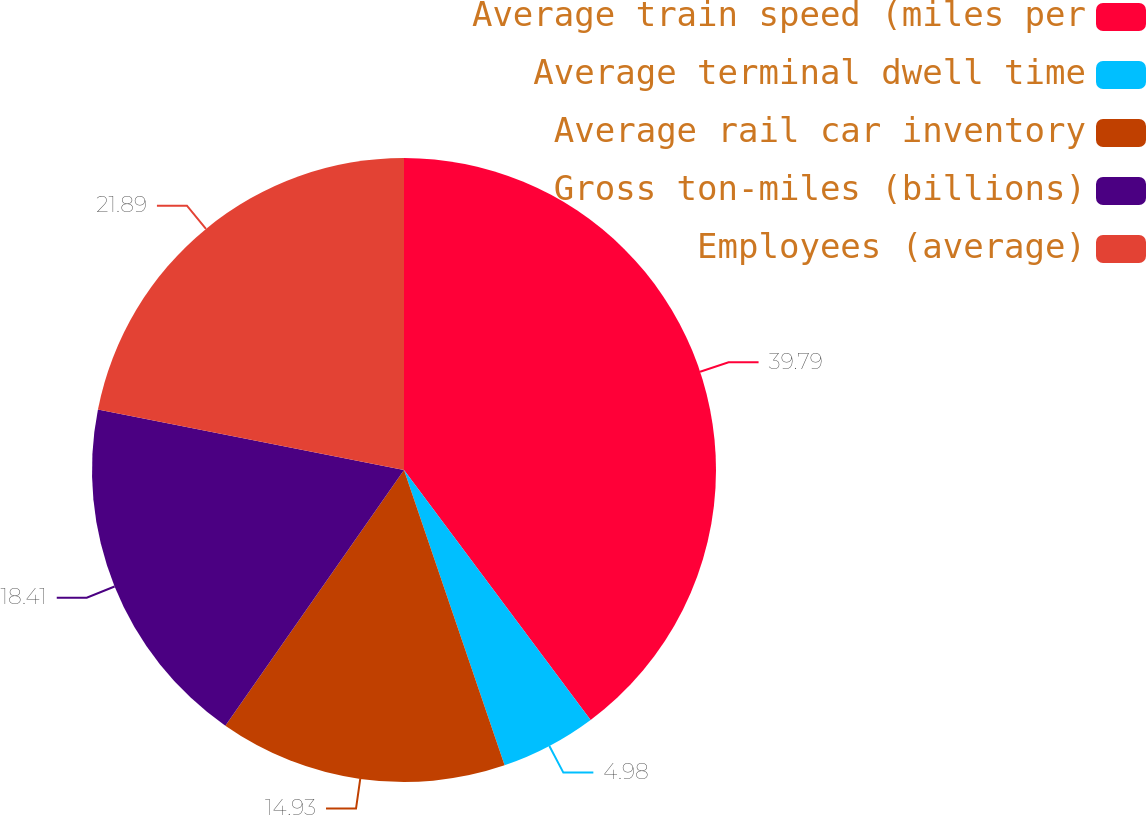<chart> <loc_0><loc_0><loc_500><loc_500><pie_chart><fcel>Average train speed (miles per<fcel>Average terminal dwell time<fcel>Average rail car inventory<fcel>Gross ton-miles (billions)<fcel>Employees (average)<nl><fcel>39.8%<fcel>4.98%<fcel>14.93%<fcel>18.41%<fcel>21.89%<nl></chart> 